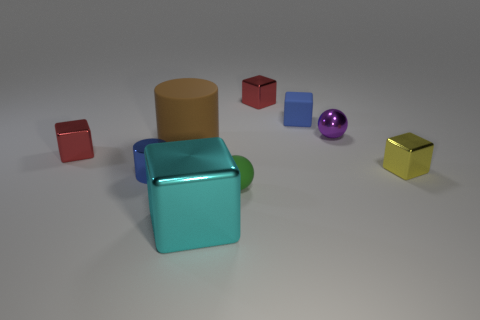How many other things are there of the same size as the rubber cube?
Provide a short and direct response. 6. How many cylinders are either matte things or small blue things?
Ensure brevity in your answer.  2. What size is the rubber thing that is to the right of the red metallic thing that is behind the red metallic object in front of the purple thing?
Ensure brevity in your answer.  Small. There is a blue matte thing; are there any tiny red shiny cubes behind it?
Offer a very short reply. Yes. There is a thing that is the same color as the matte cube; what shape is it?
Keep it short and to the point. Cylinder. What number of things are metal objects that are in front of the rubber ball or rubber objects?
Provide a succinct answer. 4. There is a cyan object that is the same material as the small purple ball; what is its size?
Make the answer very short. Large. There is a green rubber sphere; is its size the same as the cube that is to the left of the big matte thing?
Keep it short and to the point. Yes. What is the color of the small metal object that is both in front of the large brown object and right of the brown cylinder?
Provide a short and direct response. Yellow. What number of things are red metallic blocks that are to the right of the tiny cylinder or cylinders in front of the small yellow metal cube?
Offer a terse response. 2. 